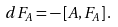<formula> <loc_0><loc_0><loc_500><loc_500>d F _ { A } = - \left [ A , F _ { A } \right ] .</formula> 